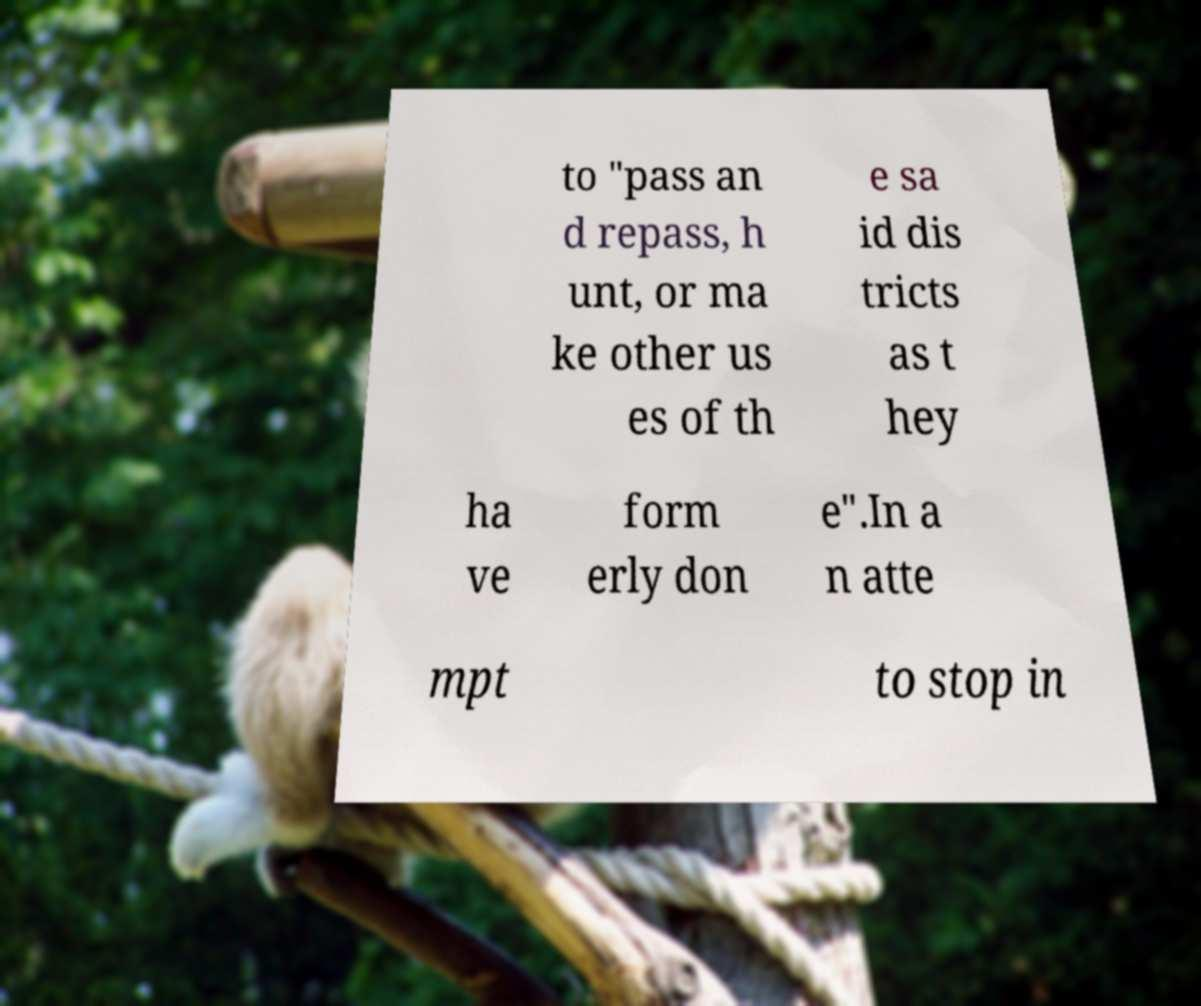Please identify and transcribe the text found in this image. to "pass an d repass, h unt, or ma ke other us es of th e sa id dis tricts as t hey ha ve form erly don e".In a n atte mpt to stop in 